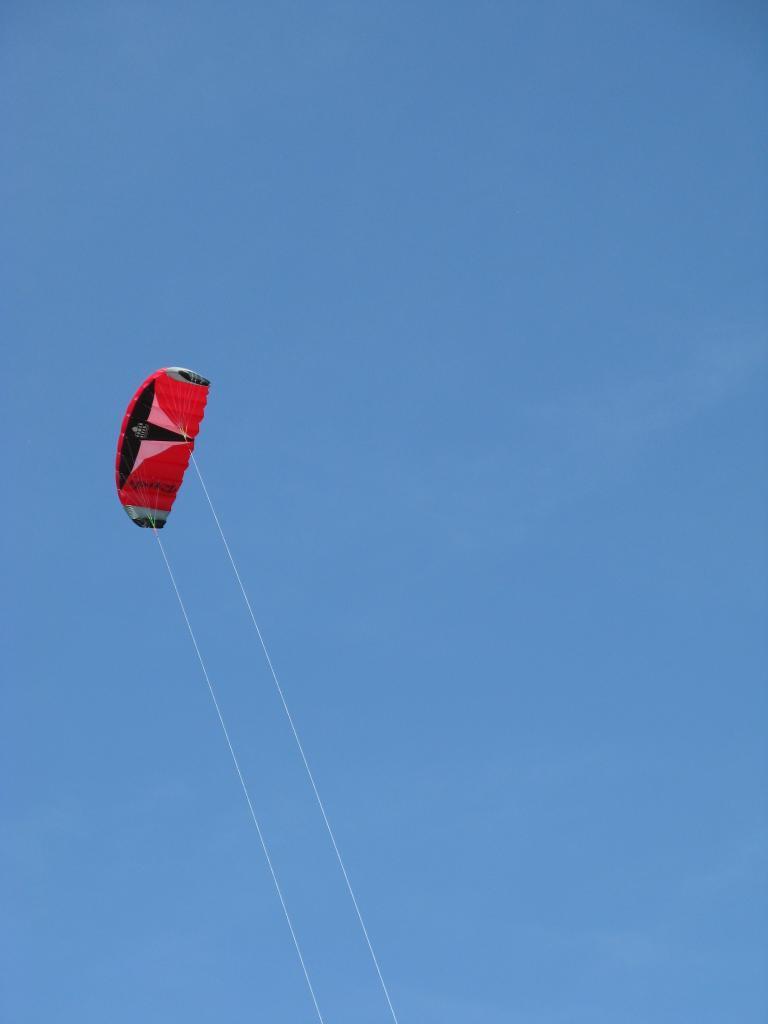How would you summarize this image in a sentence or two? There is a parachute having two threads in the air. In the background, there is blue sky. 